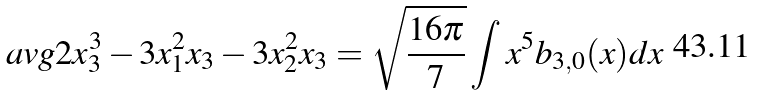Convert formula to latex. <formula><loc_0><loc_0><loc_500><loc_500>\ a v g { 2 x _ { 3 } ^ { 3 } - 3 x _ { 1 } ^ { 2 } x _ { 3 } - 3 x _ { 2 } ^ { 2 } x _ { 3 } } = \sqrt { \frac { 1 6 \pi } { 7 } } \int x ^ { 5 } b _ { 3 , 0 } ( x ) d x</formula> 